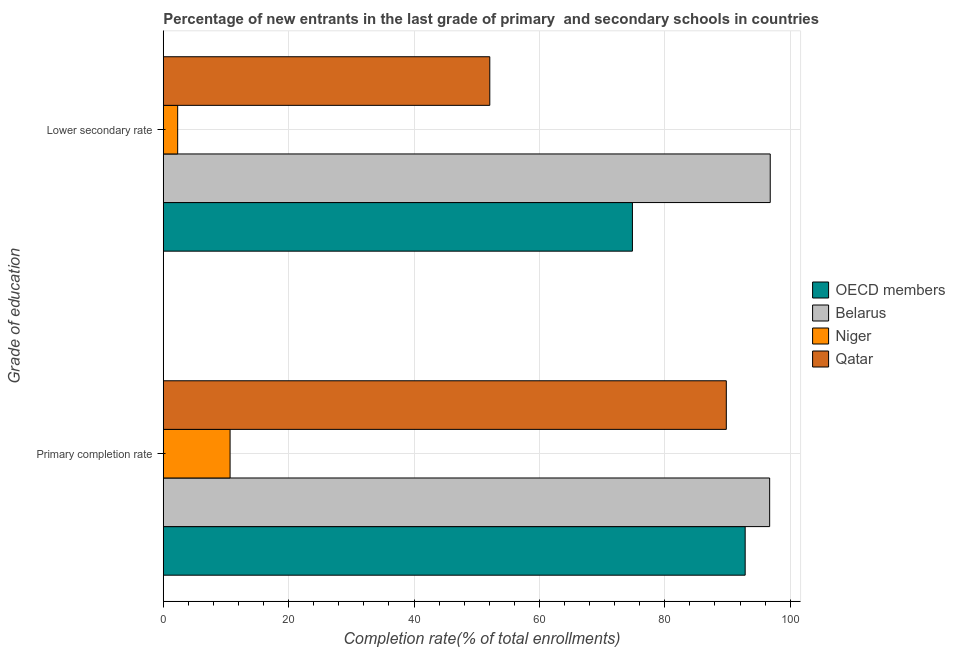How many different coloured bars are there?
Give a very brief answer. 4. Are the number of bars per tick equal to the number of legend labels?
Make the answer very short. Yes. What is the label of the 1st group of bars from the top?
Your answer should be very brief. Lower secondary rate. What is the completion rate in primary schools in Niger?
Your answer should be very brief. 10.66. Across all countries, what is the maximum completion rate in primary schools?
Provide a short and direct response. 96.73. Across all countries, what is the minimum completion rate in secondary schools?
Your answer should be compact. 2.3. In which country was the completion rate in primary schools maximum?
Ensure brevity in your answer.  Belarus. In which country was the completion rate in primary schools minimum?
Your answer should be very brief. Niger. What is the total completion rate in secondary schools in the graph?
Your answer should be very brief. 226.03. What is the difference between the completion rate in primary schools in Niger and that in OECD members?
Provide a succinct answer. -82.16. What is the difference between the completion rate in secondary schools in Belarus and the completion rate in primary schools in OECD members?
Provide a short and direct response. 4. What is the average completion rate in primary schools per country?
Your answer should be compact. 72.5. What is the difference between the completion rate in secondary schools and completion rate in primary schools in OECD members?
Your response must be concise. -17.98. In how many countries, is the completion rate in secondary schools greater than 8 %?
Give a very brief answer. 3. What is the ratio of the completion rate in primary schools in Niger to that in Belarus?
Your answer should be very brief. 0.11. Is the completion rate in secondary schools in Belarus less than that in Qatar?
Make the answer very short. No. What does the 3rd bar from the top in Lower secondary rate represents?
Keep it short and to the point. Belarus. What does the 4th bar from the bottom in Lower secondary rate represents?
Ensure brevity in your answer.  Qatar. What is the difference between two consecutive major ticks on the X-axis?
Your response must be concise. 20. Does the graph contain grids?
Give a very brief answer. Yes. How many legend labels are there?
Keep it short and to the point. 4. What is the title of the graph?
Ensure brevity in your answer.  Percentage of new entrants in the last grade of primary  and secondary schools in countries. Does "Burundi" appear as one of the legend labels in the graph?
Your answer should be compact. No. What is the label or title of the X-axis?
Give a very brief answer. Completion rate(% of total enrollments). What is the label or title of the Y-axis?
Offer a terse response. Grade of education. What is the Completion rate(% of total enrollments) in OECD members in Primary completion rate?
Provide a succinct answer. 92.82. What is the Completion rate(% of total enrollments) in Belarus in Primary completion rate?
Ensure brevity in your answer.  96.73. What is the Completion rate(% of total enrollments) of Niger in Primary completion rate?
Offer a terse response. 10.66. What is the Completion rate(% of total enrollments) in Qatar in Primary completion rate?
Your answer should be compact. 89.81. What is the Completion rate(% of total enrollments) in OECD members in Lower secondary rate?
Offer a very short reply. 74.83. What is the Completion rate(% of total enrollments) of Belarus in Lower secondary rate?
Offer a very short reply. 96.82. What is the Completion rate(% of total enrollments) in Niger in Lower secondary rate?
Give a very brief answer. 2.3. What is the Completion rate(% of total enrollments) in Qatar in Lower secondary rate?
Your answer should be very brief. 52.08. Across all Grade of education, what is the maximum Completion rate(% of total enrollments) of OECD members?
Make the answer very short. 92.82. Across all Grade of education, what is the maximum Completion rate(% of total enrollments) of Belarus?
Your answer should be compact. 96.82. Across all Grade of education, what is the maximum Completion rate(% of total enrollments) in Niger?
Offer a terse response. 10.66. Across all Grade of education, what is the maximum Completion rate(% of total enrollments) in Qatar?
Your answer should be very brief. 89.81. Across all Grade of education, what is the minimum Completion rate(% of total enrollments) in OECD members?
Ensure brevity in your answer.  74.83. Across all Grade of education, what is the minimum Completion rate(% of total enrollments) of Belarus?
Make the answer very short. 96.73. Across all Grade of education, what is the minimum Completion rate(% of total enrollments) in Niger?
Ensure brevity in your answer.  2.3. Across all Grade of education, what is the minimum Completion rate(% of total enrollments) in Qatar?
Provide a short and direct response. 52.08. What is the total Completion rate(% of total enrollments) in OECD members in the graph?
Ensure brevity in your answer.  167.65. What is the total Completion rate(% of total enrollments) of Belarus in the graph?
Your answer should be compact. 193.54. What is the total Completion rate(% of total enrollments) of Niger in the graph?
Provide a succinct answer. 12.95. What is the total Completion rate(% of total enrollments) of Qatar in the graph?
Your response must be concise. 141.9. What is the difference between the Completion rate(% of total enrollments) in OECD members in Primary completion rate and that in Lower secondary rate?
Ensure brevity in your answer.  17.98. What is the difference between the Completion rate(% of total enrollments) of Belarus in Primary completion rate and that in Lower secondary rate?
Give a very brief answer. -0.09. What is the difference between the Completion rate(% of total enrollments) in Niger in Primary completion rate and that in Lower secondary rate?
Give a very brief answer. 8.36. What is the difference between the Completion rate(% of total enrollments) of Qatar in Primary completion rate and that in Lower secondary rate?
Keep it short and to the point. 37.73. What is the difference between the Completion rate(% of total enrollments) in OECD members in Primary completion rate and the Completion rate(% of total enrollments) in Belarus in Lower secondary rate?
Your answer should be very brief. -4. What is the difference between the Completion rate(% of total enrollments) of OECD members in Primary completion rate and the Completion rate(% of total enrollments) of Niger in Lower secondary rate?
Provide a succinct answer. 90.52. What is the difference between the Completion rate(% of total enrollments) in OECD members in Primary completion rate and the Completion rate(% of total enrollments) in Qatar in Lower secondary rate?
Your answer should be compact. 40.73. What is the difference between the Completion rate(% of total enrollments) of Belarus in Primary completion rate and the Completion rate(% of total enrollments) of Niger in Lower secondary rate?
Offer a very short reply. 94.43. What is the difference between the Completion rate(% of total enrollments) in Belarus in Primary completion rate and the Completion rate(% of total enrollments) in Qatar in Lower secondary rate?
Your answer should be compact. 44.64. What is the difference between the Completion rate(% of total enrollments) in Niger in Primary completion rate and the Completion rate(% of total enrollments) in Qatar in Lower secondary rate?
Your response must be concise. -41.43. What is the average Completion rate(% of total enrollments) of OECD members per Grade of education?
Your response must be concise. 83.83. What is the average Completion rate(% of total enrollments) of Belarus per Grade of education?
Offer a terse response. 96.77. What is the average Completion rate(% of total enrollments) in Niger per Grade of education?
Your response must be concise. 6.48. What is the average Completion rate(% of total enrollments) in Qatar per Grade of education?
Offer a very short reply. 70.95. What is the difference between the Completion rate(% of total enrollments) of OECD members and Completion rate(% of total enrollments) of Belarus in Primary completion rate?
Offer a terse response. -3.91. What is the difference between the Completion rate(% of total enrollments) of OECD members and Completion rate(% of total enrollments) of Niger in Primary completion rate?
Provide a succinct answer. 82.16. What is the difference between the Completion rate(% of total enrollments) of OECD members and Completion rate(% of total enrollments) of Qatar in Primary completion rate?
Keep it short and to the point. 3.01. What is the difference between the Completion rate(% of total enrollments) in Belarus and Completion rate(% of total enrollments) in Niger in Primary completion rate?
Keep it short and to the point. 86.07. What is the difference between the Completion rate(% of total enrollments) in Belarus and Completion rate(% of total enrollments) in Qatar in Primary completion rate?
Your response must be concise. 6.91. What is the difference between the Completion rate(% of total enrollments) in Niger and Completion rate(% of total enrollments) in Qatar in Primary completion rate?
Provide a short and direct response. -79.16. What is the difference between the Completion rate(% of total enrollments) of OECD members and Completion rate(% of total enrollments) of Belarus in Lower secondary rate?
Your answer should be compact. -21.98. What is the difference between the Completion rate(% of total enrollments) of OECD members and Completion rate(% of total enrollments) of Niger in Lower secondary rate?
Your answer should be compact. 72.54. What is the difference between the Completion rate(% of total enrollments) in OECD members and Completion rate(% of total enrollments) in Qatar in Lower secondary rate?
Your answer should be very brief. 22.75. What is the difference between the Completion rate(% of total enrollments) of Belarus and Completion rate(% of total enrollments) of Niger in Lower secondary rate?
Provide a short and direct response. 94.52. What is the difference between the Completion rate(% of total enrollments) of Belarus and Completion rate(% of total enrollments) of Qatar in Lower secondary rate?
Your response must be concise. 44.73. What is the difference between the Completion rate(% of total enrollments) in Niger and Completion rate(% of total enrollments) in Qatar in Lower secondary rate?
Make the answer very short. -49.79. What is the ratio of the Completion rate(% of total enrollments) of OECD members in Primary completion rate to that in Lower secondary rate?
Your response must be concise. 1.24. What is the ratio of the Completion rate(% of total enrollments) of Belarus in Primary completion rate to that in Lower secondary rate?
Keep it short and to the point. 1. What is the ratio of the Completion rate(% of total enrollments) of Niger in Primary completion rate to that in Lower secondary rate?
Your answer should be very brief. 4.64. What is the ratio of the Completion rate(% of total enrollments) in Qatar in Primary completion rate to that in Lower secondary rate?
Your answer should be very brief. 1.72. What is the difference between the highest and the second highest Completion rate(% of total enrollments) in OECD members?
Make the answer very short. 17.98. What is the difference between the highest and the second highest Completion rate(% of total enrollments) of Belarus?
Keep it short and to the point. 0.09. What is the difference between the highest and the second highest Completion rate(% of total enrollments) in Niger?
Your answer should be very brief. 8.36. What is the difference between the highest and the second highest Completion rate(% of total enrollments) in Qatar?
Your answer should be compact. 37.73. What is the difference between the highest and the lowest Completion rate(% of total enrollments) of OECD members?
Ensure brevity in your answer.  17.98. What is the difference between the highest and the lowest Completion rate(% of total enrollments) in Belarus?
Provide a succinct answer. 0.09. What is the difference between the highest and the lowest Completion rate(% of total enrollments) of Niger?
Your answer should be compact. 8.36. What is the difference between the highest and the lowest Completion rate(% of total enrollments) of Qatar?
Keep it short and to the point. 37.73. 